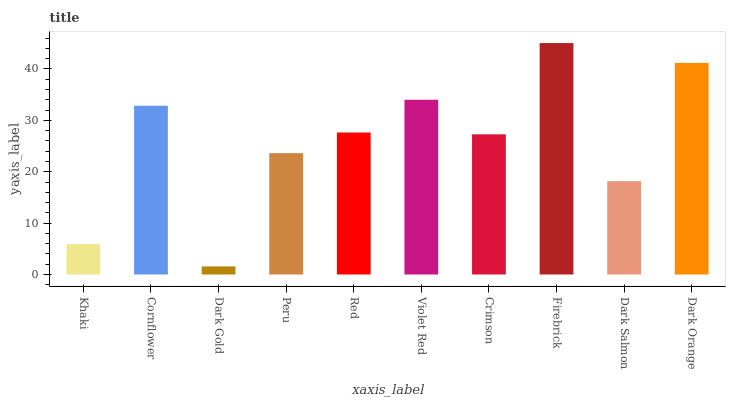Is Dark Gold the minimum?
Answer yes or no. Yes. Is Firebrick the maximum?
Answer yes or no. Yes. Is Cornflower the minimum?
Answer yes or no. No. Is Cornflower the maximum?
Answer yes or no. No. Is Cornflower greater than Khaki?
Answer yes or no. Yes. Is Khaki less than Cornflower?
Answer yes or no. Yes. Is Khaki greater than Cornflower?
Answer yes or no. No. Is Cornflower less than Khaki?
Answer yes or no. No. Is Red the high median?
Answer yes or no. Yes. Is Crimson the low median?
Answer yes or no. Yes. Is Peru the high median?
Answer yes or no. No. Is Firebrick the low median?
Answer yes or no. No. 